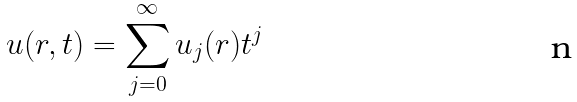<formula> <loc_0><loc_0><loc_500><loc_500>u ( r , t ) = \sum _ { j = 0 } ^ { \infty } u _ { j } ( r ) t ^ { j }</formula> 